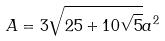<formula> <loc_0><loc_0><loc_500><loc_500>A = 3 \sqrt { 2 5 + 1 0 \sqrt { 5 } } a ^ { 2 }</formula> 